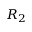<formula> <loc_0><loc_0><loc_500><loc_500>R _ { 2 }</formula> 